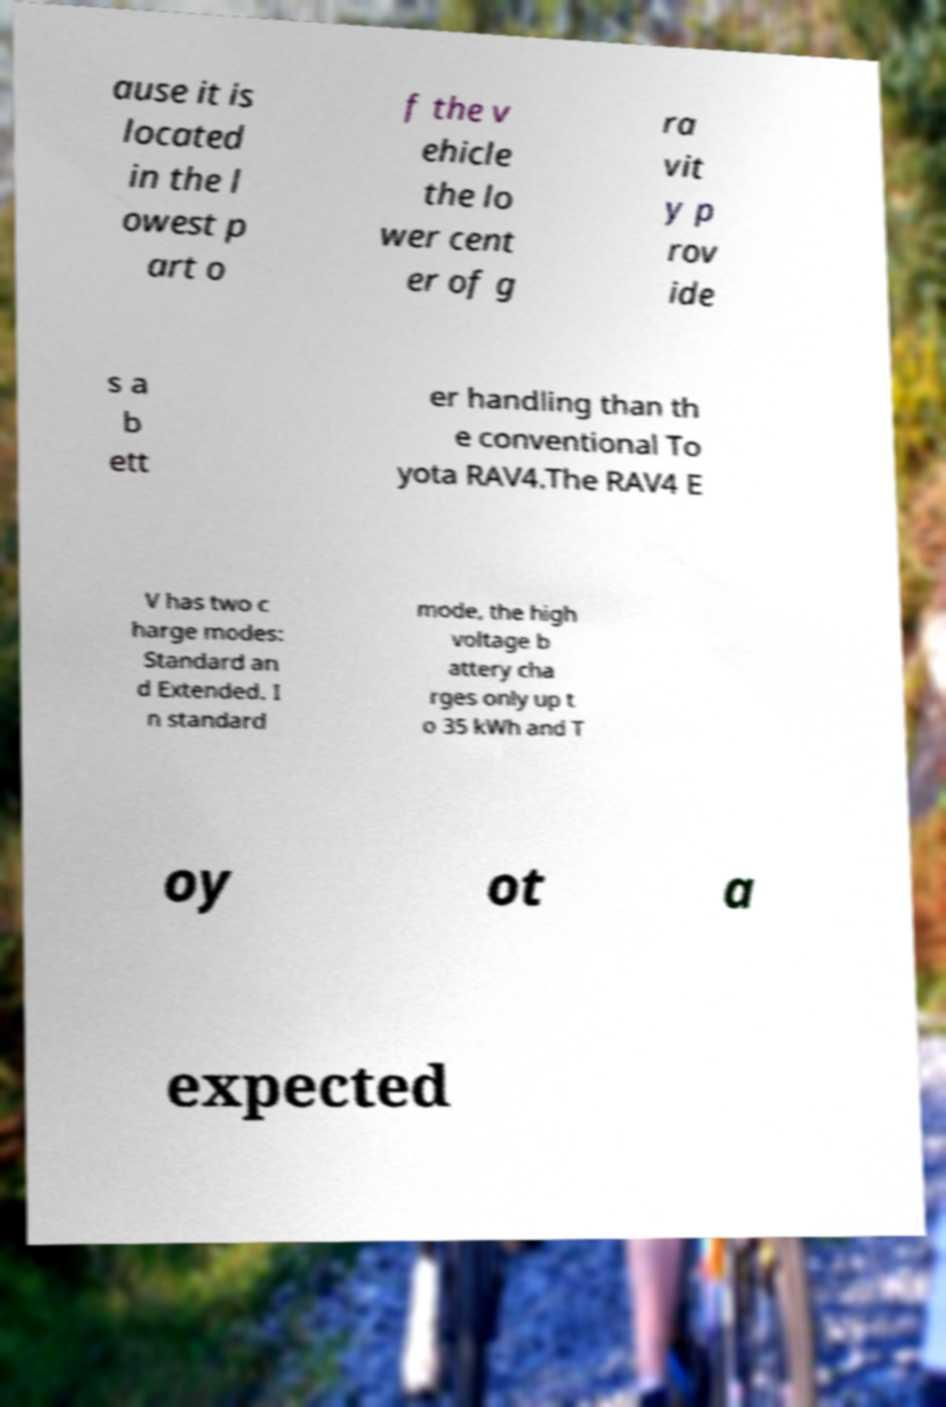Could you extract and type out the text from this image? ause it is located in the l owest p art o f the v ehicle the lo wer cent er of g ra vit y p rov ide s a b ett er handling than th e conventional To yota RAV4.The RAV4 E V has two c harge modes: Standard an d Extended. I n standard mode, the high voltage b attery cha rges only up t o 35 kWh and T oy ot a expected 